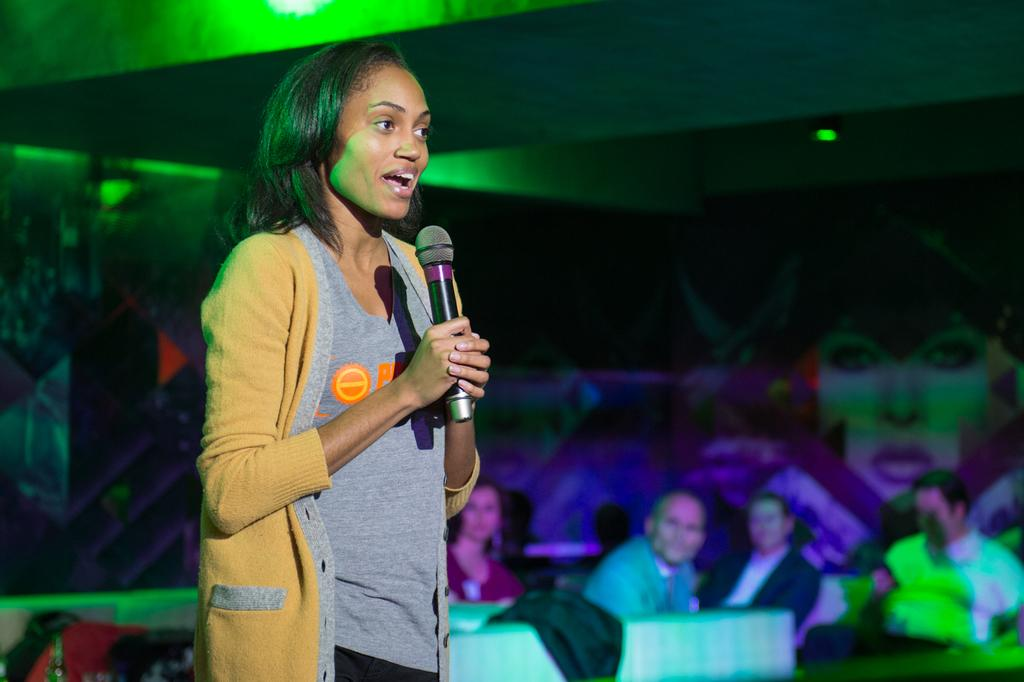Who is the main subject in the image? There is a woman in the image. What is the woman doing in the image? The woman is standing and talking into a microphone. What are the other people in the image doing? There are many people sitting in the image. What can be observed about the lighting in the image? There are many lights present in the image. What invention does the woman's uncle have that is related to the microphone in the image? There is no mention of an invention or the woman's uncle in the image, so it cannot be determined from the image. 